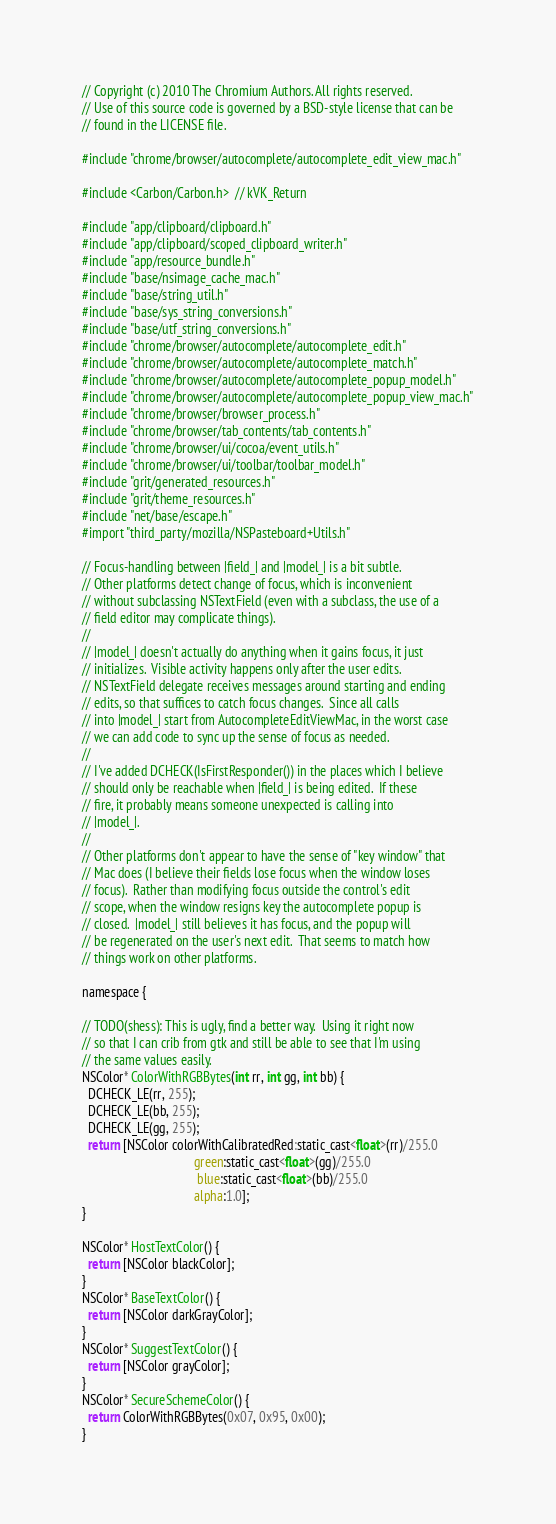Convert code to text. <code><loc_0><loc_0><loc_500><loc_500><_ObjectiveC_>// Copyright (c) 2010 The Chromium Authors. All rights reserved.
// Use of this source code is governed by a BSD-style license that can be
// found in the LICENSE file.

#include "chrome/browser/autocomplete/autocomplete_edit_view_mac.h"

#include <Carbon/Carbon.h>  // kVK_Return

#include "app/clipboard/clipboard.h"
#include "app/clipboard/scoped_clipboard_writer.h"
#include "app/resource_bundle.h"
#include "base/nsimage_cache_mac.h"
#include "base/string_util.h"
#include "base/sys_string_conversions.h"
#include "base/utf_string_conversions.h"
#include "chrome/browser/autocomplete/autocomplete_edit.h"
#include "chrome/browser/autocomplete/autocomplete_match.h"
#include "chrome/browser/autocomplete/autocomplete_popup_model.h"
#include "chrome/browser/autocomplete/autocomplete_popup_view_mac.h"
#include "chrome/browser/browser_process.h"
#include "chrome/browser/tab_contents/tab_contents.h"
#include "chrome/browser/ui/cocoa/event_utils.h"
#include "chrome/browser/ui/toolbar/toolbar_model.h"
#include "grit/generated_resources.h"
#include "grit/theme_resources.h"
#include "net/base/escape.h"
#import "third_party/mozilla/NSPasteboard+Utils.h"

// Focus-handling between |field_| and |model_| is a bit subtle.
// Other platforms detect change of focus, which is inconvenient
// without subclassing NSTextField (even with a subclass, the use of a
// field editor may complicate things).
//
// |model_| doesn't actually do anything when it gains focus, it just
// initializes.  Visible activity happens only after the user edits.
// NSTextField delegate receives messages around starting and ending
// edits, so that suffices to catch focus changes.  Since all calls
// into |model_| start from AutocompleteEditViewMac, in the worst case
// we can add code to sync up the sense of focus as needed.
//
// I've added DCHECK(IsFirstResponder()) in the places which I believe
// should only be reachable when |field_| is being edited.  If these
// fire, it probably means someone unexpected is calling into
// |model_|.
//
// Other platforms don't appear to have the sense of "key window" that
// Mac does (I believe their fields lose focus when the window loses
// focus).  Rather than modifying focus outside the control's edit
// scope, when the window resigns key the autocomplete popup is
// closed.  |model_| still believes it has focus, and the popup will
// be regenerated on the user's next edit.  That seems to match how
// things work on other platforms.

namespace {

// TODO(shess): This is ugly, find a better way.  Using it right now
// so that I can crib from gtk and still be able to see that I'm using
// the same values easily.
NSColor* ColorWithRGBBytes(int rr, int gg, int bb) {
  DCHECK_LE(rr, 255);
  DCHECK_LE(bb, 255);
  DCHECK_LE(gg, 255);
  return [NSColor colorWithCalibratedRed:static_cast<float>(rr)/255.0
                                   green:static_cast<float>(gg)/255.0
                                    blue:static_cast<float>(bb)/255.0
                                   alpha:1.0];
}

NSColor* HostTextColor() {
  return [NSColor blackColor];
}
NSColor* BaseTextColor() {
  return [NSColor darkGrayColor];
}
NSColor* SuggestTextColor() {
  return [NSColor grayColor];
}
NSColor* SecureSchemeColor() {
  return ColorWithRGBBytes(0x07, 0x95, 0x00);
}</code> 